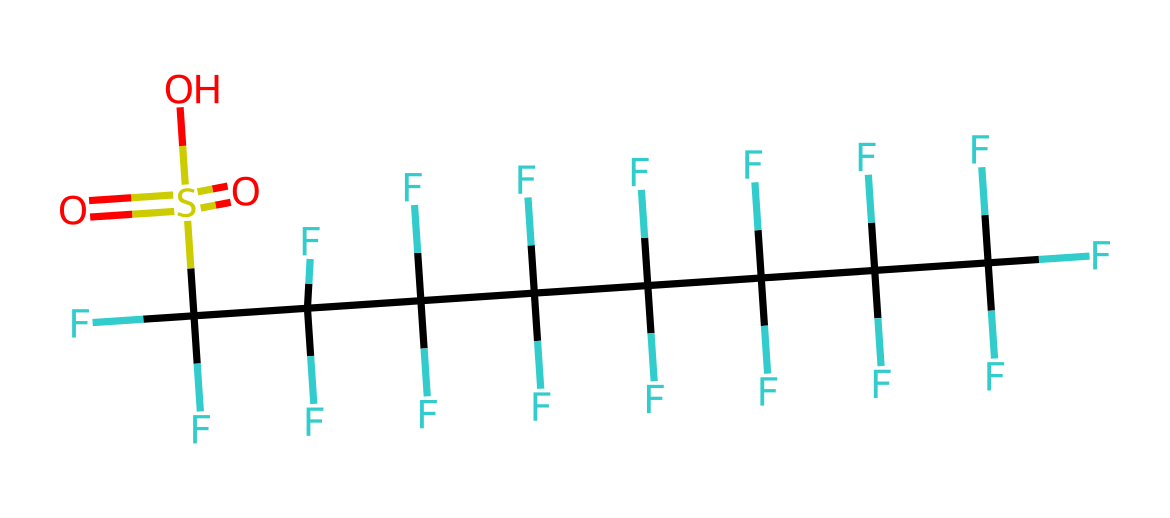What type of functional group is present in this molecule? The molecule contains a sulfonic acid group (-SO3H), as indicated by the presence of sulfur bonded to three oxygens, with one oxygen having a hydrogen attached.
Answer: sulfonic acid How many fluorine atoms are in the molecule? By examining the structure, each carbon is bonded to three fluorine atoms, and there are a total of eight carbon atoms in the chain. Thus, the total count is 24 fluorine atoms (8 carbon atoms * 3 fluorine atoms each).
Answer: 24 What is the total number of carbon atoms in the molecule? Counting the carbon atoms directly from the structure, there are a total of eight carbon atoms present in the carbon chain.
Answer: 8 What does the presence of many fluorine atoms indicate about the chemical properties of this molecule? The high number of fluorine atoms suggests that the molecule is highly hydrophobic and provides water-repellent properties, as fluorine atoms are known to enhance the water resistance of chemicals.
Answer: hydrophobic What is likely the purpose of this chemical in outdoor gear? The chemical structure, with its hydrophobic properties and water-repellent capabilities, is likely used as a waterproofing agent in outdoor gear, helping to keep materials dry.
Answer: waterproofing agent 